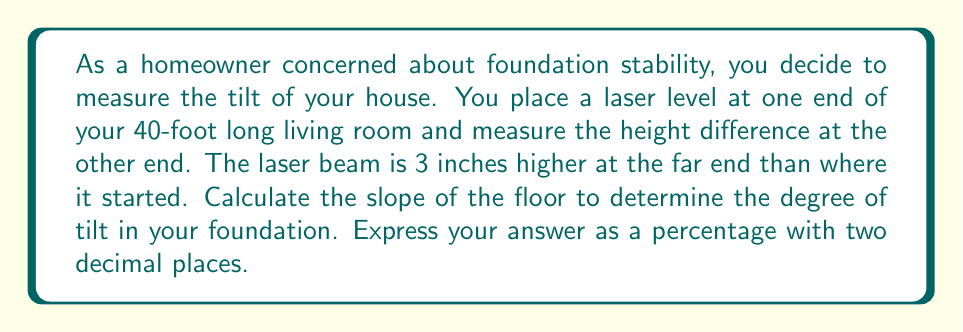Could you help me with this problem? To solve this problem, we need to calculate the slope of the line representing the floor and convert it to a percentage. Let's break it down step-by-step:

1) The slope of a line is defined as the change in y (rise) divided by the change in x (run):

   $$ \text{slope} = \frac{\text{rise}}{\text{run}} $$

2) In this case:
   - The run is the length of the room: 40 feet
   - The rise is the height difference: 3 inches

3) We need to convert inches to feet for consistency:
   $$ 3 \text{ inches} = 3 \div 12 = 0.25 \text{ feet} $$

4) Now we can calculate the slope:
   $$ \text{slope} = \frac{0.25 \text{ feet}}{40 \text{ feet}} = \frac{1}{160} = 0.00625 $$

5) To convert the slope to a percentage, we multiply by 100:
   $$ 0.00625 \times 100 = 0.625\% $$

6) Rounding to two decimal places gives us 0.63%.

This means the floor rises 0.63% over its length, indicating the degree of tilt in your foundation.
Answer: 0.63% 